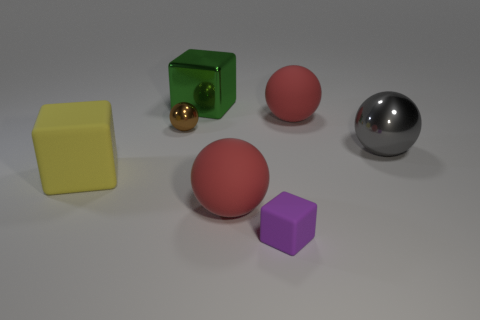Subtract all green cubes. How many cubes are left? 2 Add 1 matte blocks. How many objects exist? 8 Subtract all red balls. How many balls are left? 2 Subtract all balls. How many objects are left? 3 Subtract 2 blocks. How many blocks are left? 1 Subtract all red spheres. Subtract all yellow cylinders. How many spheres are left? 2 Subtract all purple cubes. How many brown spheres are left? 1 Subtract all small purple objects. Subtract all big matte cubes. How many objects are left? 5 Add 1 yellow blocks. How many yellow blocks are left? 2 Add 3 metallic objects. How many metallic objects exist? 6 